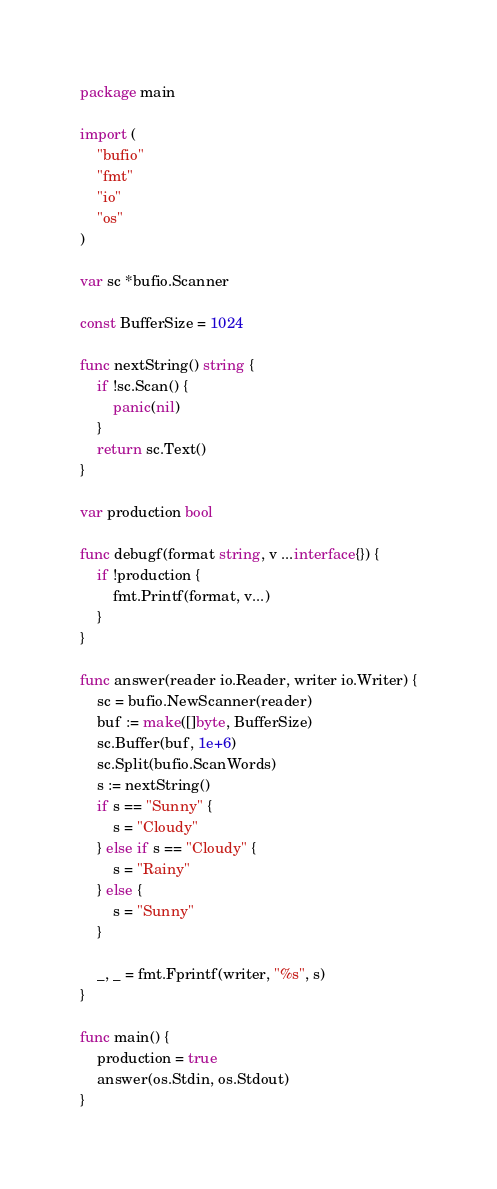<code> <loc_0><loc_0><loc_500><loc_500><_Go_>package main

import (
	"bufio"
	"fmt"
	"io"
	"os"
)

var sc *bufio.Scanner

const BufferSize = 1024

func nextString() string {
	if !sc.Scan() {
		panic(nil)
	}
	return sc.Text()
}

var production bool

func debugf(format string, v ...interface{}) {
	if !production {
		fmt.Printf(format, v...)
	}
}

func answer(reader io.Reader, writer io.Writer) {
	sc = bufio.NewScanner(reader)
	buf := make([]byte, BufferSize)
	sc.Buffer(buf, 1e+6)
	sc.Split(bufio.ScanWords)
	s := nextString()
	if s == "Sunny" {
		s = "Cloudy"
	} else if s == "Cloudy" {
		s = "Rainy"
	} else {
		s = "Sunny"
	}

	_, _ = fmt.Fprintf(writer, "%s", s)
}

func main() {
	production = true
	answer(os.Stdin, os.Stdout)
}
</code> 